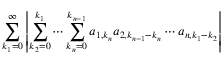<formula> <loc_0><loc_0><loc_500><loc_500>\sum _ { k _ { 1 } = 0 } ^ { \infty } \left | \sum _ { k _ { 2 } = 0 } ^ { k _ { 1 } } \cdots \sum _ { k _ { n } = 0 } ^ { k _ { n - 1 } } a _ { 1 , k _ { n } } a _ { 2 , k _ { n - 1 } - k _ { n } } \cdots a _ { n , k _ { 1 } - k _ { 2 } } \right |</formula> 